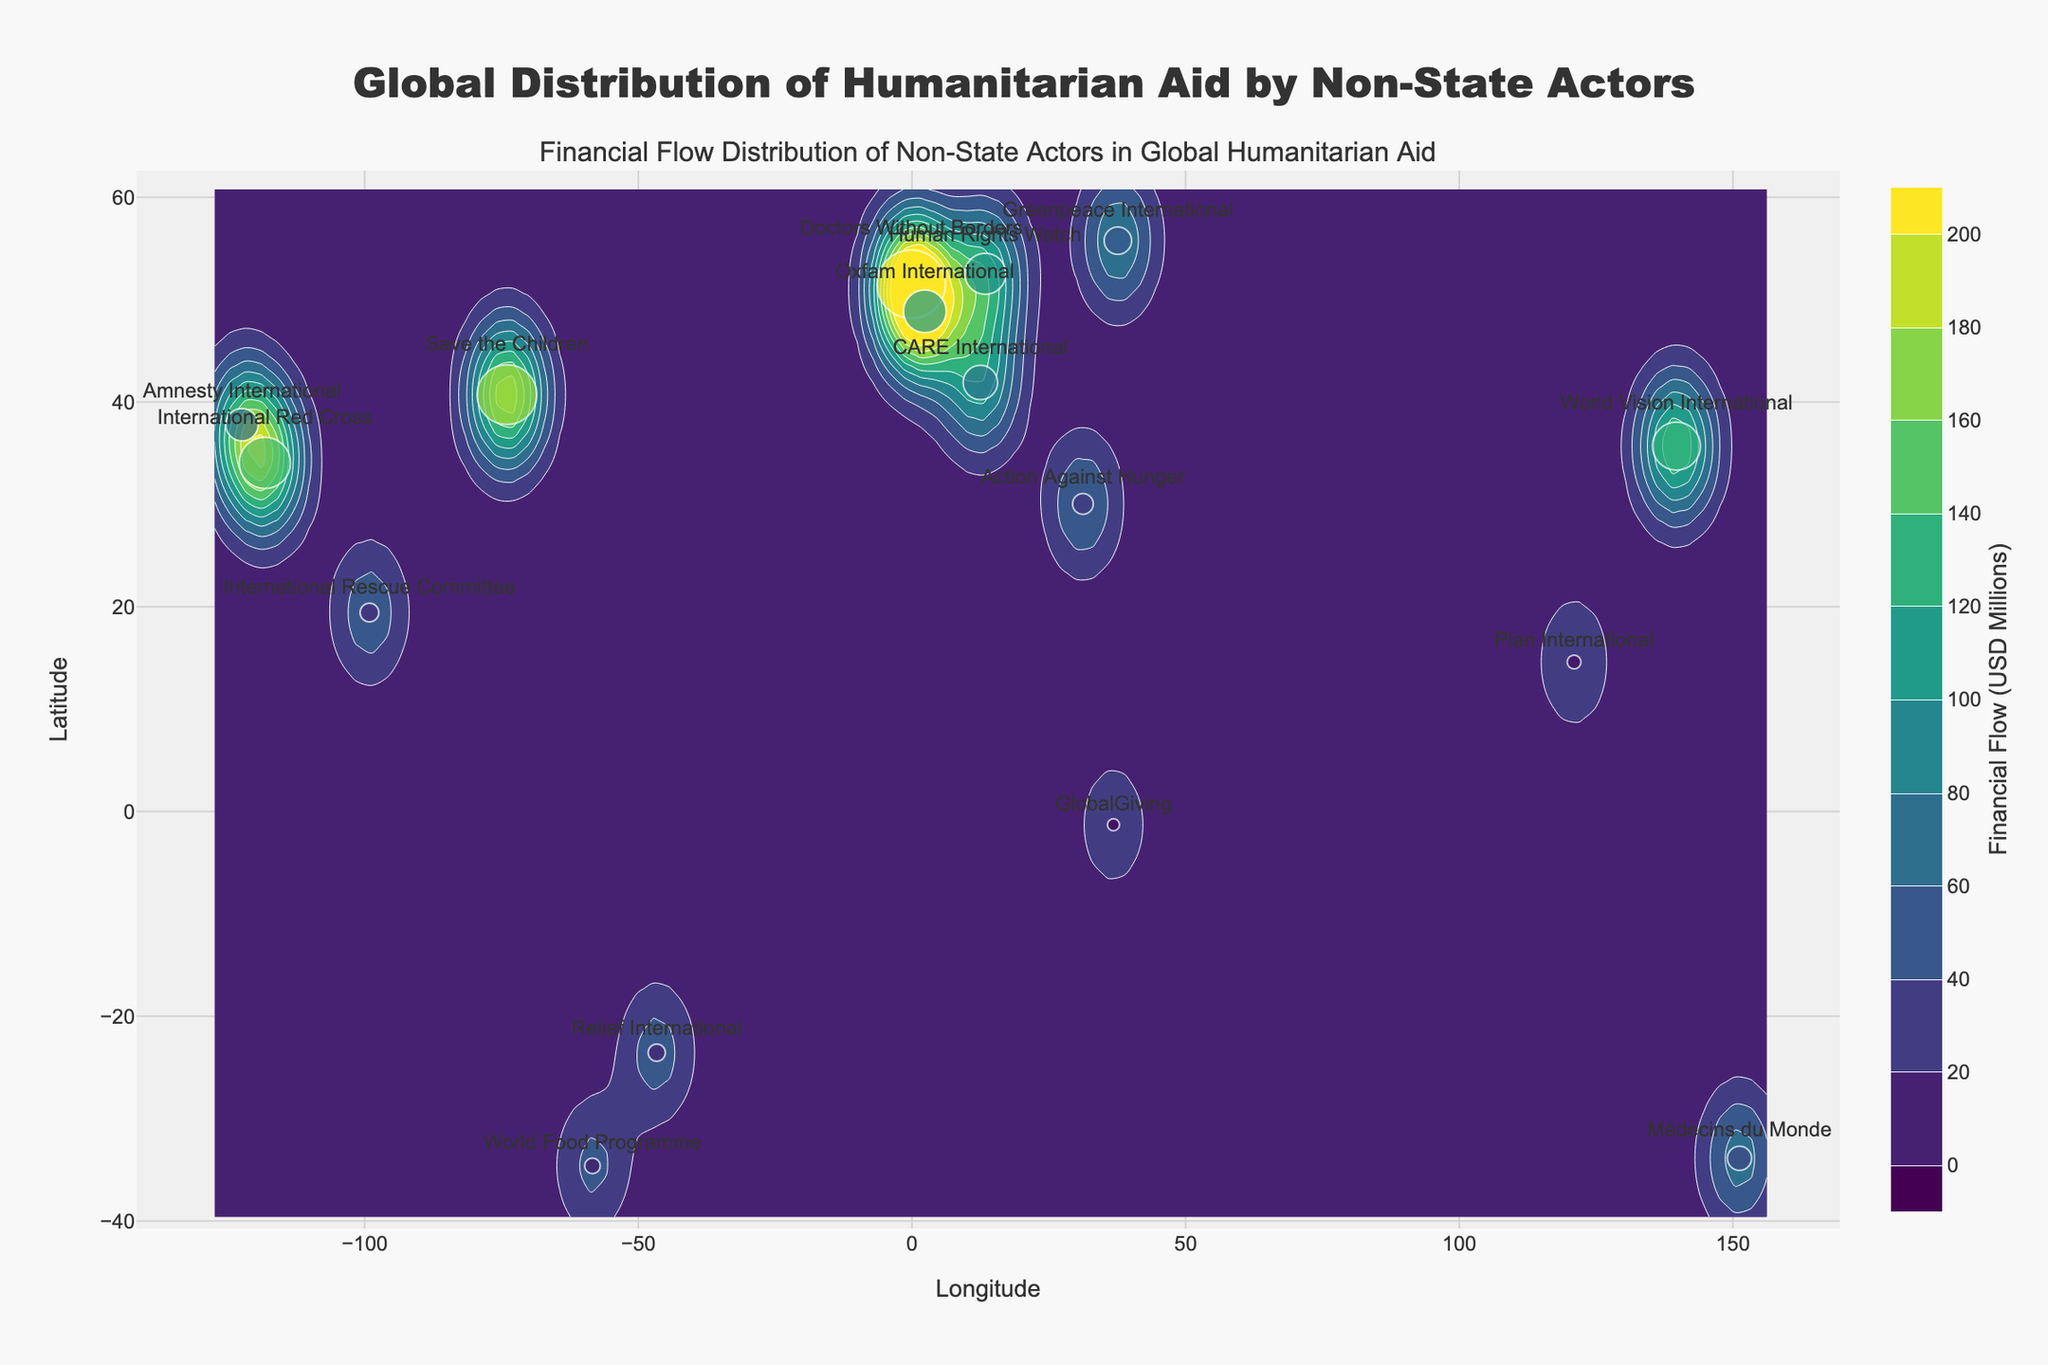What's the title of the figure? The title of the figure is located at the top center and reads 'Global Distribution of Humanitarian Aid by Non-State Actors', which indicates the main topic of the plot.
Answer: Global Distribution of Humanitarian Aid by Non-State Actors What is the color scale used in the contour plot? The contour plot uses a 'Viridis' color scale, visible in the gradient bar that runs from a dark blue to a yellowish-green, representing increasing financial flow values.
Answer: Viridis How many non-state actors are labeled on the plot? By counting each unique label associated with marked points on the scatter plot, there are 16 non-state actors represented.
Answer: 16 Which non-state actor has the highest financial flow, and what is its value? The actor labeled "Doctors Without Borders" has the highest financial flow, located approximately at (51.5074, -0.1278) with a value of 200.5 million USD, extracted from the size and value of the marker.
Answer: Doctors Without Borders, 200.5 million USD What is the longitude and latitude range covered by the plot? The longitude range is from approximately -123 to 154 and latitude range is from approximately -39 to 54, identified by the axis labels.
Answer: Longitude: -123 to 154, Latitude: -39 to 54 Describe the pattern of financial flow distribution depicted by the contour lines. The contour lines show concentric, irregularly shaped areas with varying heights, where higher financial flows are concentrated around specific longitude and latitude points, particularly in locations like London, New York, and Los Angeles.
Answer: High around major cities, concentric circles Which two non-state actors have the closest financial flow values, and what are they? "World Vision International" (140.6 million USD) and "International Red Cross" (150.2 million USD) have close financial flows. By comparing their markers' sizes and corresponding financial values next to them.
Answer: World Vision International (140.6 million USD), International Red Cross (150.2 million USD) What is the average financial flow value of the non-state actors presented in the plot? Sum of financial flows is 150.2+200.5+175.0+125.4+100.8+140.6+80.3+95.2+120.3+60.7+70.9+55.0+45.8+35.3+40.4+50.5 = 1546.6; divide by 16 (number of actors) gives: 1546.6/16 = 96.66 million USD.
Answer: 96.66 million USD Which non-state actor is represented with the smallest marker on the plot, and what is its financial flow? "GlobalGiving" is depicted with the smallest marker at (1.2921, 36.8219), indicating the smallest financial flow of 35.3 million USD.
Answer: GlobalGiving, 35.3 million USD What financial flow value is represented by the marker located at approximately (33.8688, 151.2093)? The non-state actor "Médecins du Monde" is at those coordinates, with a financial flow of 70.9 million USD, as identified by the label next to the marker.
Answer: 70.9 million USD 